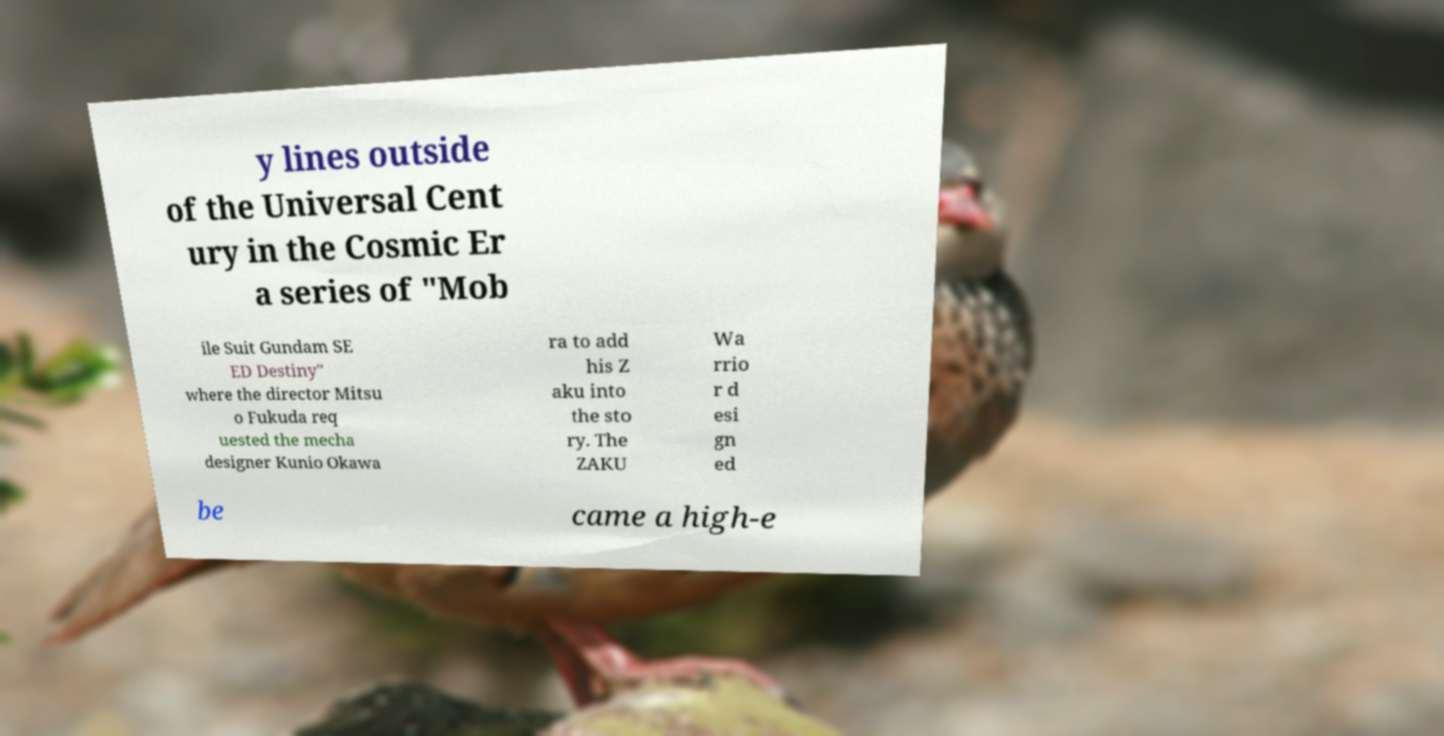What messages or text are displayed in this image? I need them in a readable, typed format. y lines outside of the Universal Cent ury in the Cosmic Er a series of "Mob ile Suit Gundam SE ED Destiny" where the director Mitsu o Fukuda req uested the mecha designer Kunio Okawa ra to add his Z aku into the sto ry. The ZAKU Wa rrio r d esi gn ed be came a high-e 